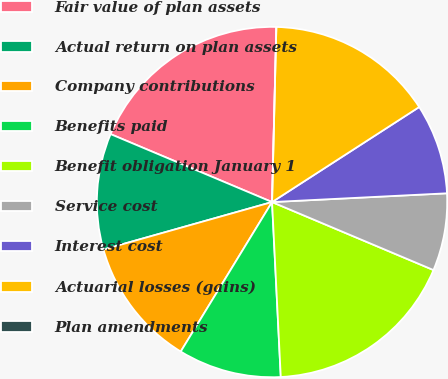Convert chart to OTSL. <chart><loc_0><loc_0><loc_500><loc_500><pie_chart><fcel>Fair value of plan assets<fcel>Actual return on plan assets<fcel>Company contributions<fcel>Benefits paid<fcel>Benefit obligation January 1<fcel>Service cost<fcel>Interest cost<fcel>Actuarial losses (gains)<fcel>Plan amendments<nl><fcel>19.05%<fcel>10.71%<fcel>11.9%<fcel>9.52%<fcel>17.86%<fcel>7.14%<fcel>8.33%<fcel>15.48%<fcel>0.0%<nl></chart> 